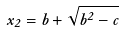<formula> <loc_0><loc_0><loc_500><loc_500>x _ { 2 } = b + \sqrt { b ^ { 2 } - c }</formula> 